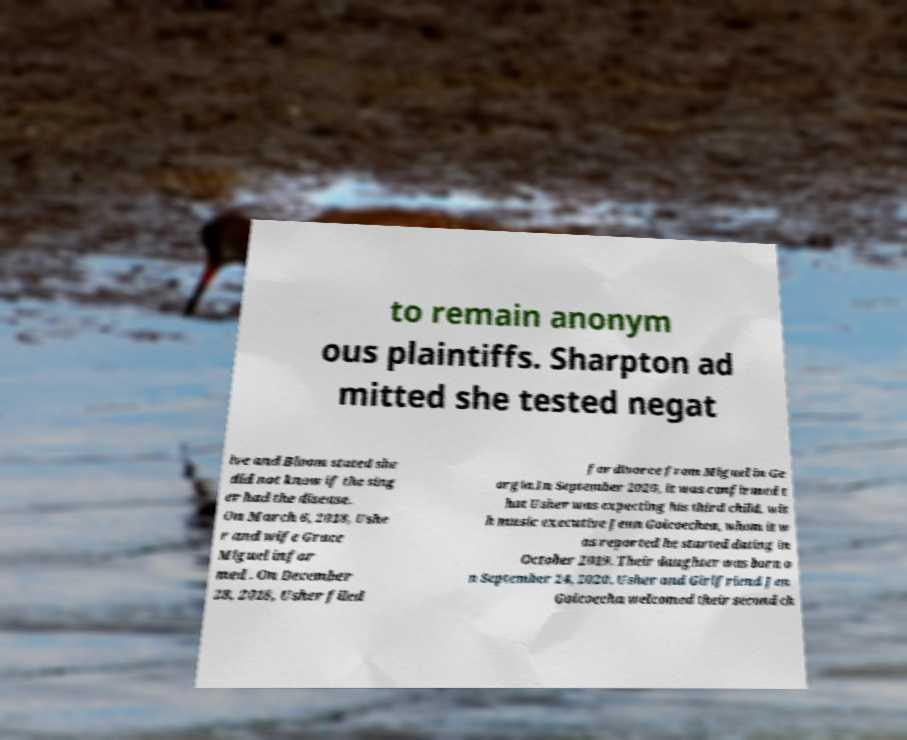For documentation purposes, I need the text within this image transcribed. Could you provide that? to remain anonym ous plaintiffs. Sharpton ad mitted she tested negat ive and Bloom stated she did not know if the sing er had the disease. On March 6, 2018, Ushe r and wife Grace Miguel infor med . On December 28, 2018, Usher filed for divorce from Miguel in Ge orgia.In September 2020, it was confirmed t hat Usher was expecting his third child, wit h music executive Jenn Goicoechea, whom it w as reported he started dating in October 2019. Their daughter was born o n September 24, 2020. Usher and Girlfriend Jen Goicoecha welcomed their second ch 